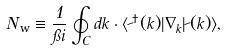Convert formula to latex. <formula><loc_0><loc_0><loc_500><loc_500>N _ { \text {w} } \equiv \frac { 1 } { \pi i } \oint _ { C } d k \cdot \langle \psi ^ { \dag } ( k ) | \nabla _ { k } | \psi ( k ) \rangle ,</formula> 